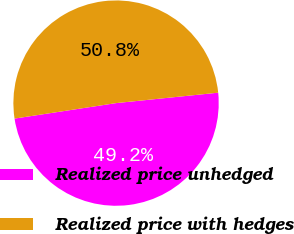Convert chart to OTSL. <chart><loc_0><loc_0><loc_500><loc_500><pie_chart><fcel>Realized price unhedged<fcel>Realized price with hedges<nl><fcel>49.21%<fcel>50.79%<nl></chart> 